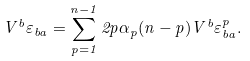Convert formula to latex. <formula><loc_0><loc_0><loc_500><loc_500>V ^ { b } \varepsilon _ { b a } = \sum _ { p = 1 } ^ { n - 1 } 2 p \alpha _ { p } ( n - p ) V ^ { b } \varepsilon _ { b a } ^ { p } .</formula> 